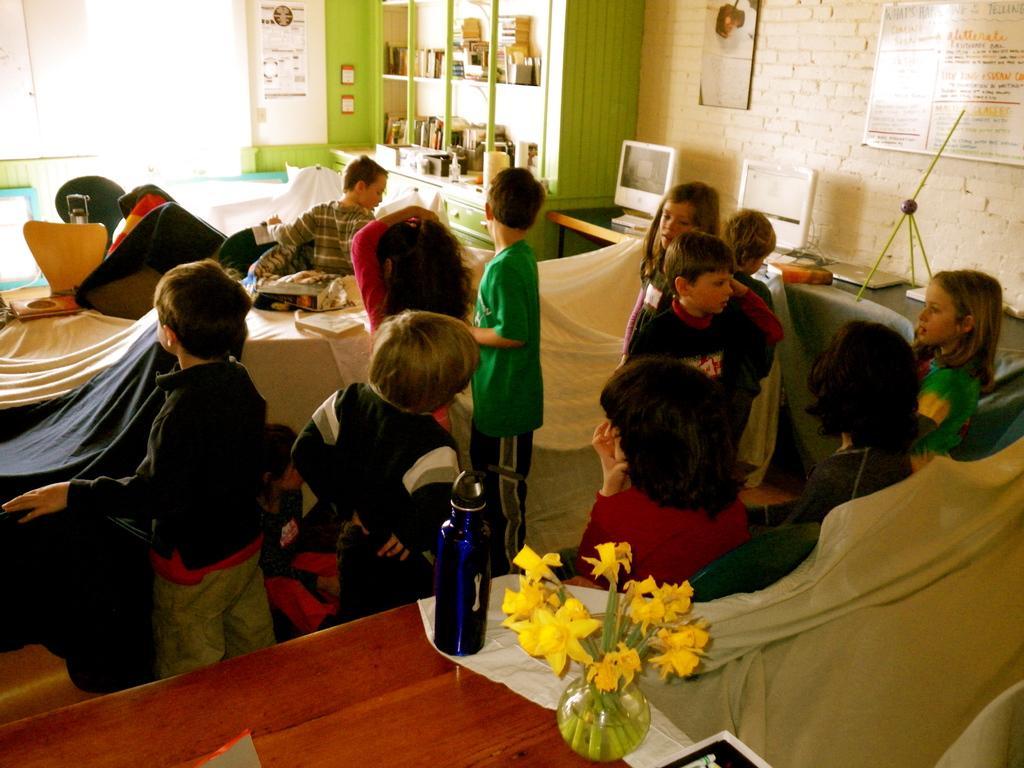How would you summarize this image in a sentence or two? So many people in a room playing with the chairs and tables behind them there are water bottle flower vase and a shelf with some things in it. 